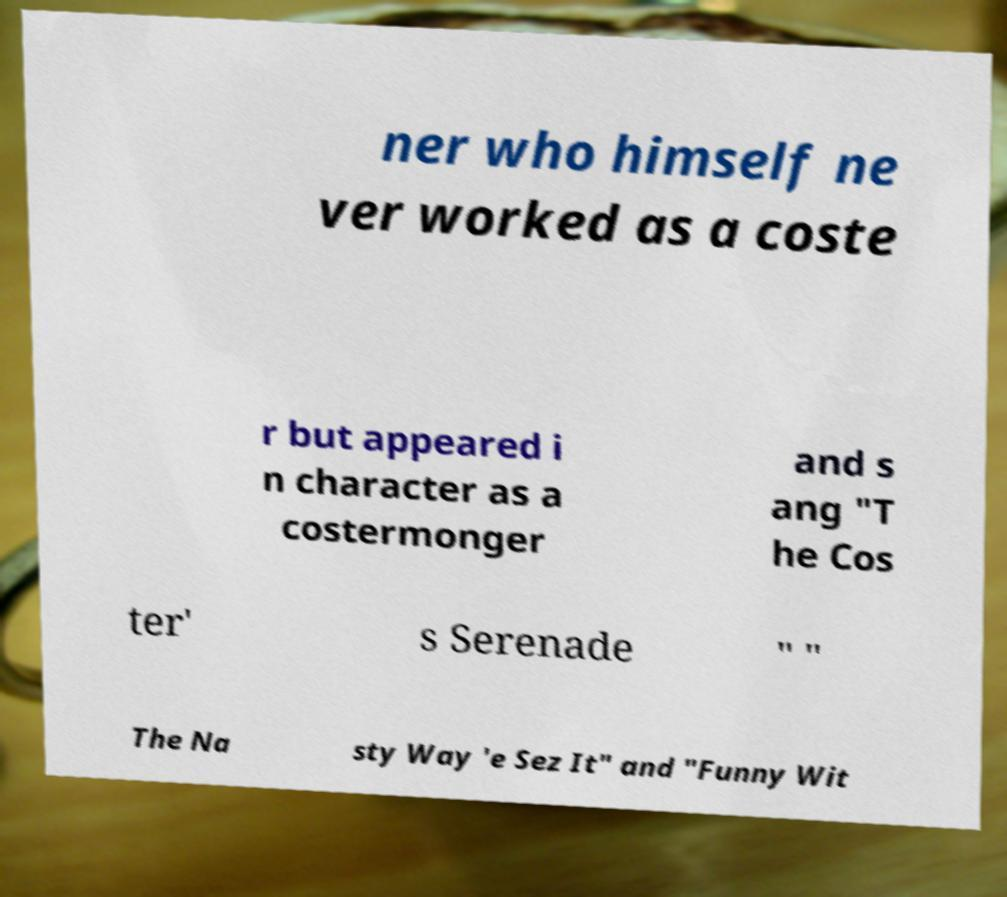Please read and relay the text visible in this image. What does it say? ner who himself ne ver worked as a coste r but appeared i n character as a costermonger and s ang "T he Cos ter' s Serenade " " The Na sty Way 'e Sez It" and "Funny Wit 